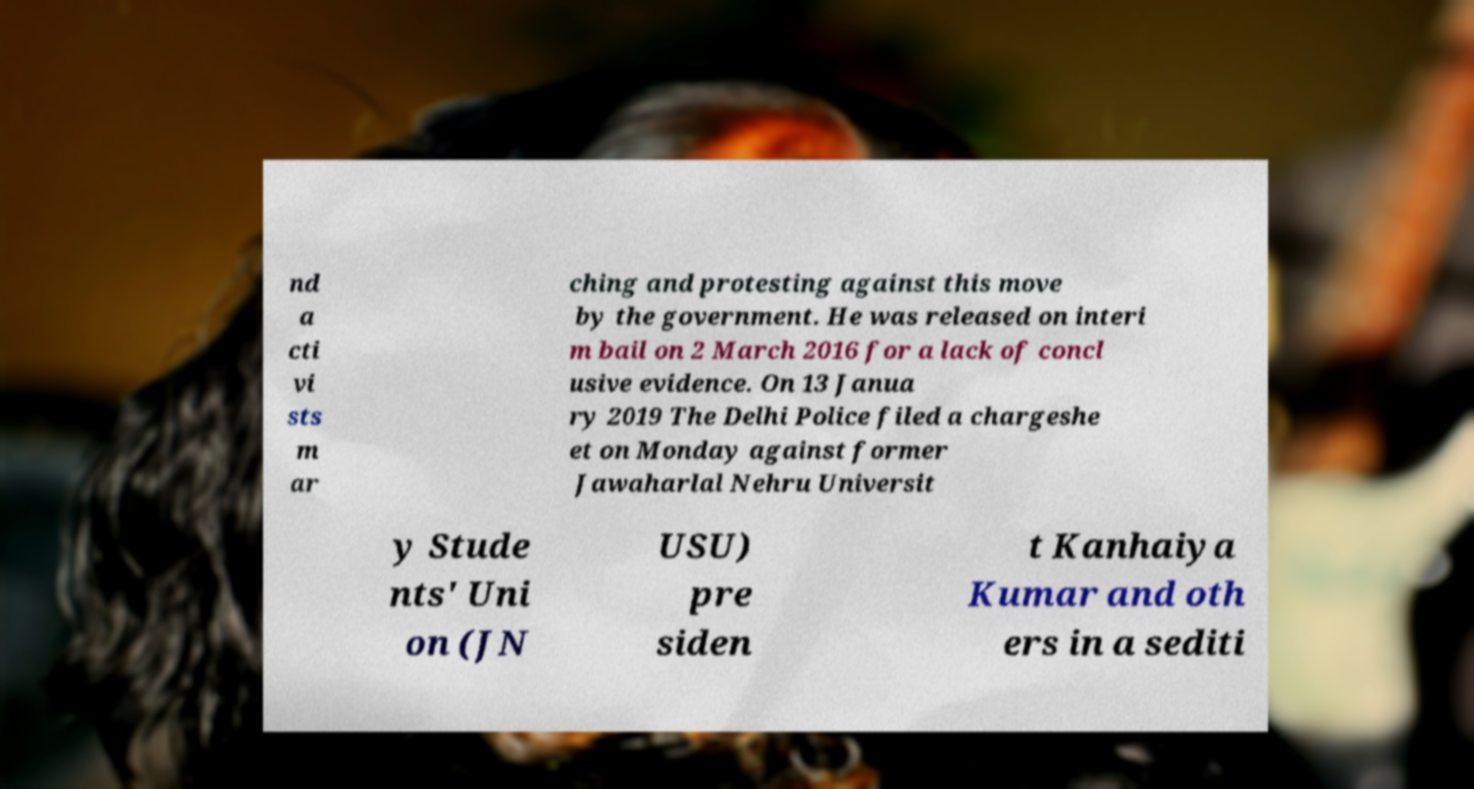There's text embedded in this image that I need extracted. Can you transcribe it verbatim? nd a cti vi sts m ar ching and protesting against this move by the government. He was released on interi m bail on 2 March 2016 for a lack of concl usive evidence. On 13 Janua ry 2019 The Delhi Police filed a chargeshe et on Monday against former Jawaharlal Nehru Universit y Stude nts' Uni on (JN USU) pre siden t Kanhaiya Kumar and oth ers in a sediti 